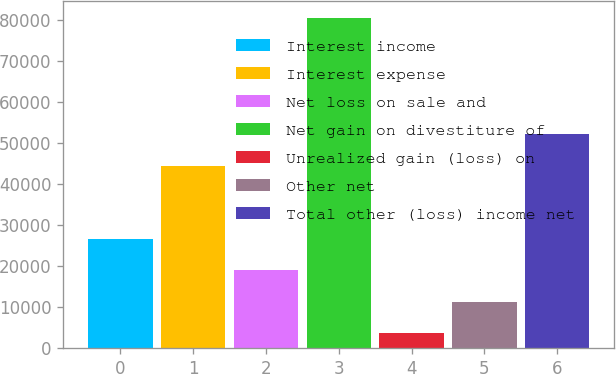Convert chart to OTSL. <chart><loc_0><loc_0><loc_500><loc_500><bar_chart><fcel>Interest income<fcel>Interest expense<fcel>Net loss on sale and<fcel>Net gain on divestiture of<fcel>Unrealized gain (loss) on<fcel>Other net<fcel>Total other (loss) income net<nl><fcel>26692.6<fcel>44391<fcel>19000.4<fcel>80538<fcel>3616<fcel>11308.2<fcel>52083.2<nl></chart> 